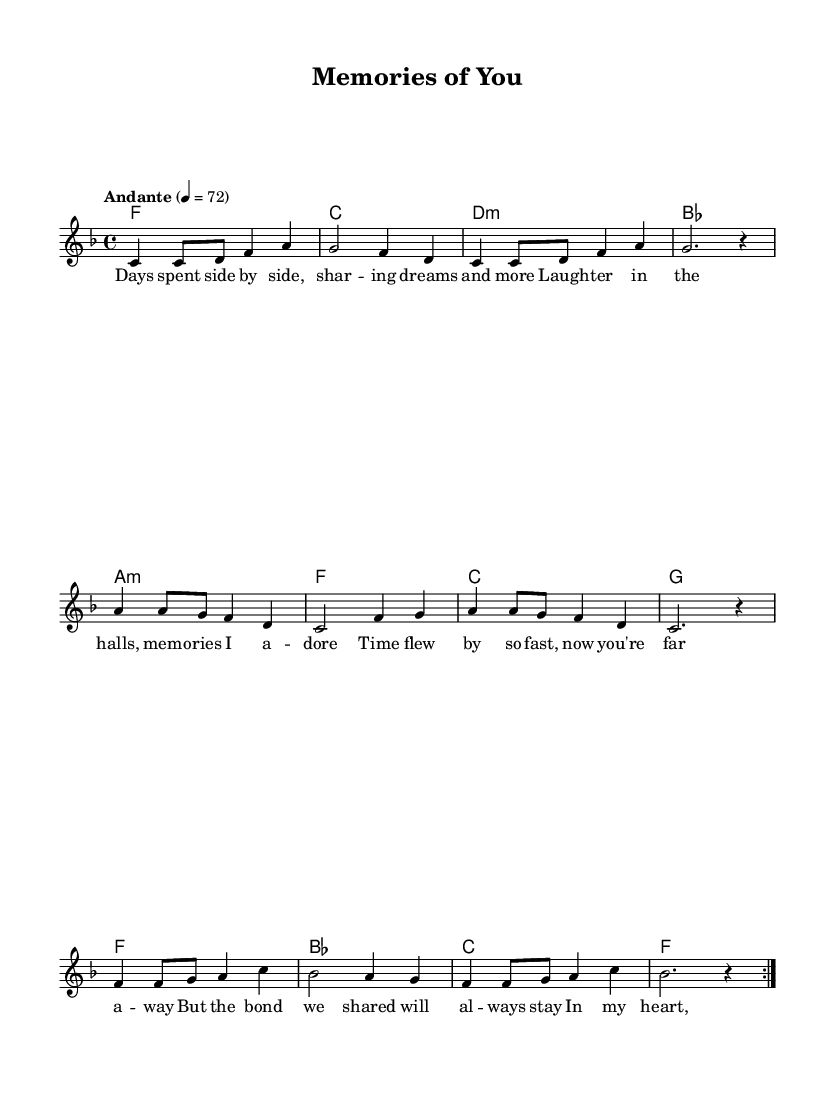What is the key signature of this music? The key signature is F major, indicated by the presence of one flat (B flat). This is identifiable by looking at the key signature at the beginning of the staff.
Answer: F major What is the time signature of this music? The time signature is four-four, indicated by the "4/4" written at the beginning of the score. This means there are four beats per measure and the quarter note gets one beat.
Answer: Four-four What is the tempo marking for this piece? The tempo marking is "Andante," which means a moderate walking pace. It is indicated by the word "Andante" alongside the metronome marking of 72 beats per minute, located near the beginning of the score.
Answer: Andante How many times is the melody repeated in the piece? The melody is repeated two times, as specified by the "repeat volta 2" instruction written in the melody section, indicating a repeated section meant to be played twice.
Answer: Two What type of song structure is displayed in this piece? This piece follows a verse structure, as indicated by the lyrics that reflect a narrative aspect typical in ballads which build emotional connections, hinting at workplace relationships and friendships.
Answer: Verse What style of music does this piece represent? This piece represents the K-Pop genre, identifiable from the lyrical themes and melodic structure typical of K-Pop ballads which often explore emotions related to relationships, friendship, and personal experiences in a modern context.
Answer: K-Pop How does the lyrical content contribute to the musical theme? The lyrics evoke nostalgia and the bonds of friendship, emphasizing shared experiences and emotional connections, themes which resonate deeply in soulful ballads, particularly in the K-Pop genre where storytelling is key.
Answer: Nostalgia and friendship 